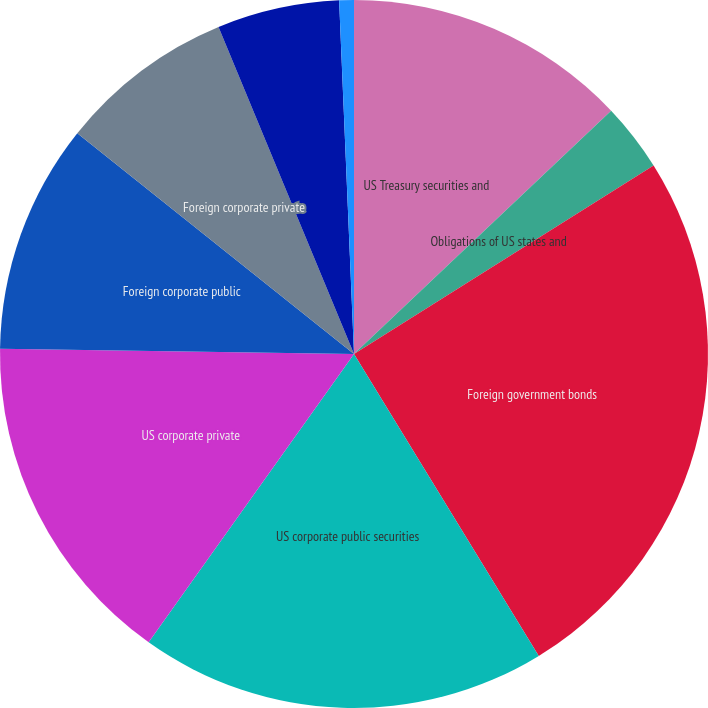Convert chart. <chart><loc_0><loc_0><loc_500><loc_500><pie_chart><fcel>US Treasury securities and<fcel>Obligations of US states and<fcel>Foreign government bonds<fcel>US corporate public securities<fcel>US corporate private<fcel>Foreign corporate public<fcel>Foreign corporate private<fcel>Asset-backed securities(2)<fcel>Residential mortgage-backed<nl><fcel>12.94%<fcel>3.12%<fcel>25.2%<fcel>18.59%<fcel>15.39%<fcel>10.48%<fcel>8.03%<fcel>5.58%<fcel>0.67%<nl></chart> 